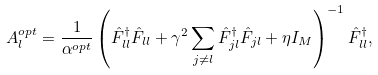<formula> <loc_0><loc_0><loc_500><loc_500>A _ { l } ^ { o p t } = \frac { 1 } { \alpha ^ { o p t } } \left ( \hat { F } _ { l l } ^ { \dagger } \hat { F } _ { l l } + \gamma ^ { 2 } \sum _ { j \ne l } \hat { F } _ { j l } ^ { \dagger } \hat { F } _ { j l } + \eta I _ { M } \right ) ^ { - 1 } \hat { F } _ { l l } ^ { \dagger } ,</formula> 